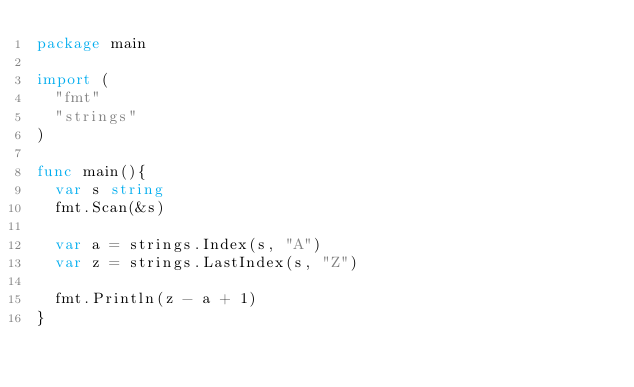<code> <loc_0><loc_0><loc_500><loc_500><_Go_>package main

import (
	"fmt"
	"strings"
)

func main(){
	var s string
	fmt.Scan(&s)

	var a = strings.Index(s, "A")
	var z = strings.LastIndex(s, "Z")

	fmt.Println(z - a + 1)
}
</code> 